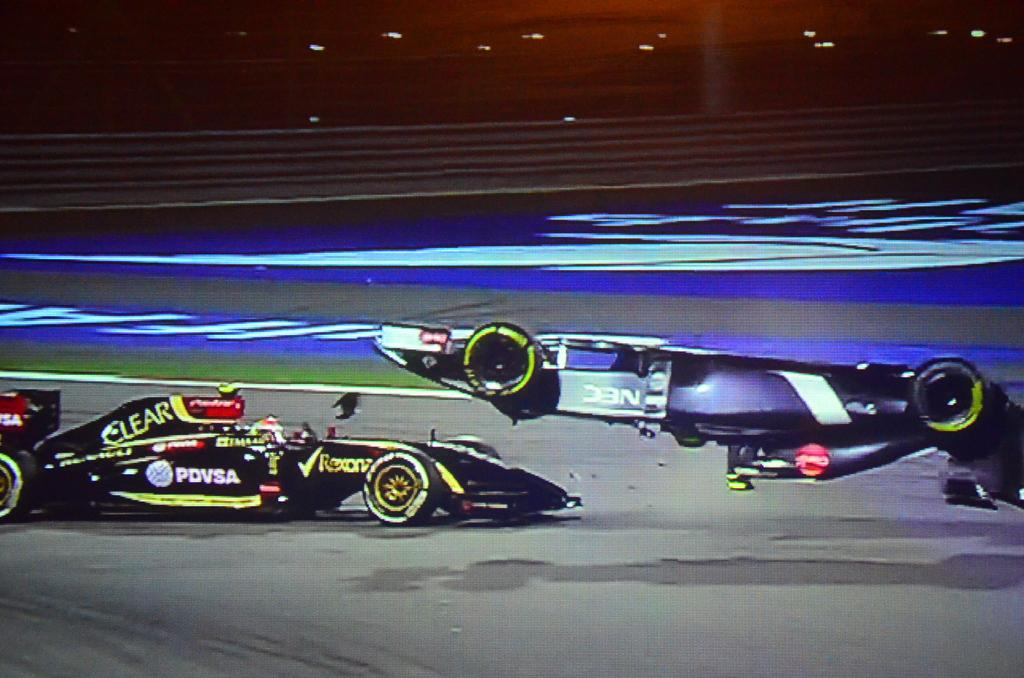<image>
Relay a brief, clear account of the picture shown. an f1 car is flipping on another car with PDVSA on the side 